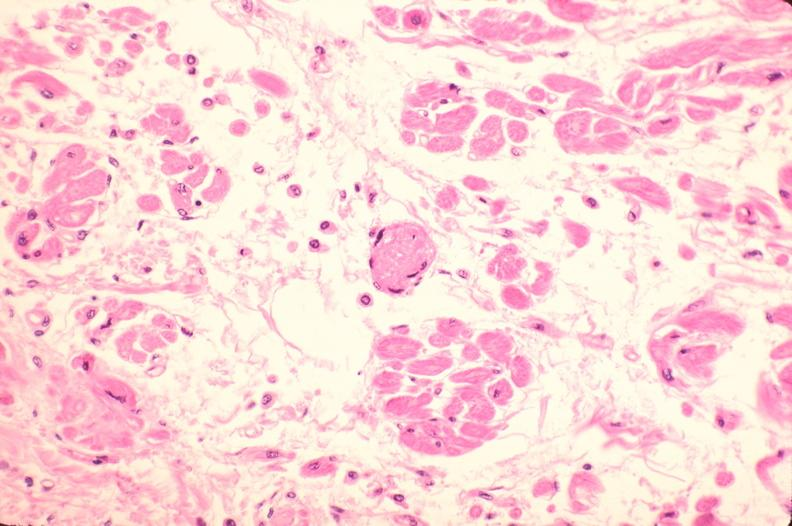what is present?
Answer the question using a single word or phrase. Cardiovascular 